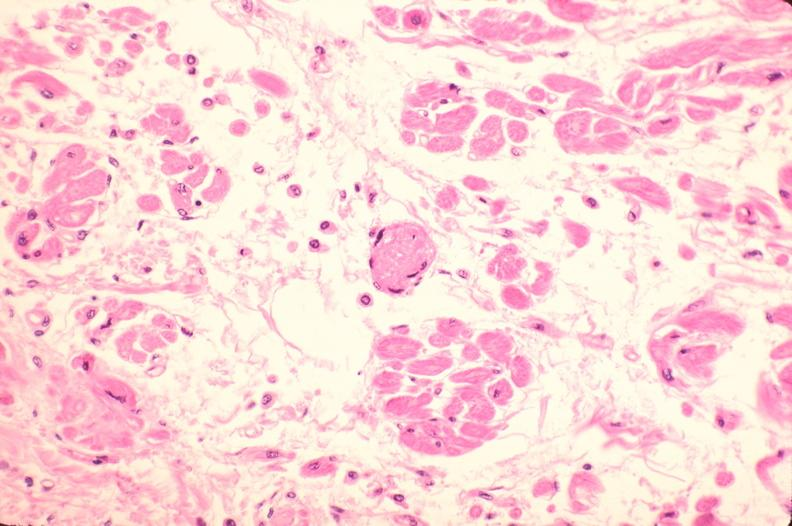what is present?
Answer the question using a single word or phrase. Cardiovascular 